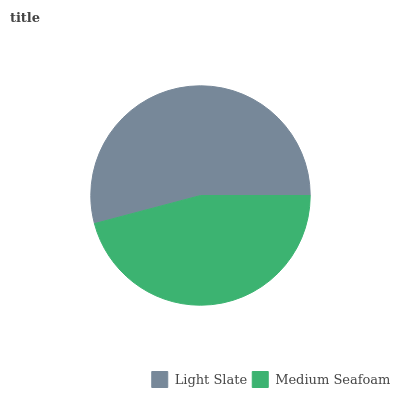Is Medium Seafoam the minimum?
Answer yes or no. Yes. Is Light Slate the maximum?
Answer yes or no. Yes. Is Medium Seafoam the maximum?
Answer yes or no. No. Is Light Slate greater than Medium Seafoam?
Answer yes or no. Yes. Is Medium Seafoam less than Light Slate?
Answer yes or no. Yes. Is Medium Seafoam greater than Light Slate?
Answer yes or no. No. Is Light Slate less than Medium Seafoam?
Answer yes or no. No. Is Light Slate the high median?
Answer yes or no. Yes. Is Medium Seafoam the low median?
Answer yes or no. Yes. Is Medium Seafoam the high median?
Answer yes or no. No. Is Light Slate the low median?
Answer yes or no. No. 